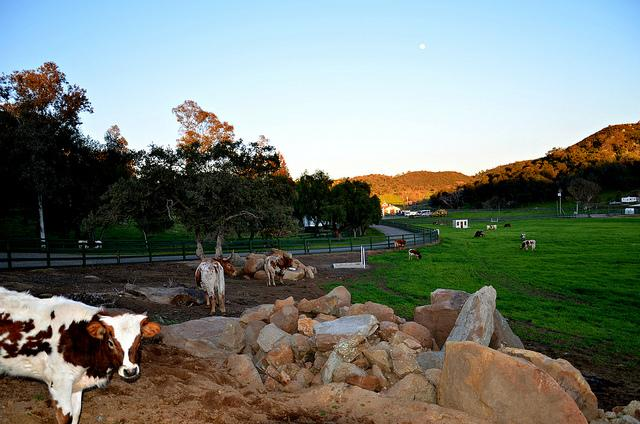What colors are on the cow closest to the camera? Please explain your reasoning. brown white. Brown and white 